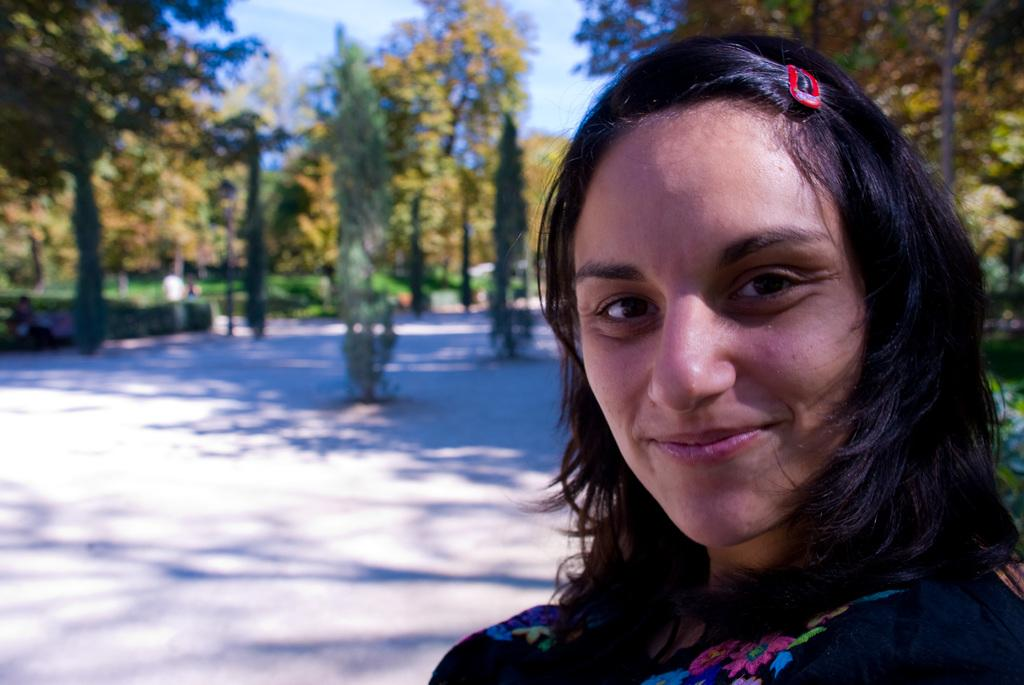What is the main subject of the image? There is a beautiful woman in the image. What expression does the woman have? The woman is smiling. What type of natural environment can be seen in the image? There are trees visible in the image. Can you describe the setting of the image? The setting appears to be a park. What type of box can be seen in the image? There is no box present in the image. What is the woman's love interest in the image? The image does not provide any information about the woman's love interest. Where is the playground located in the image? There is no playground present in the image. 